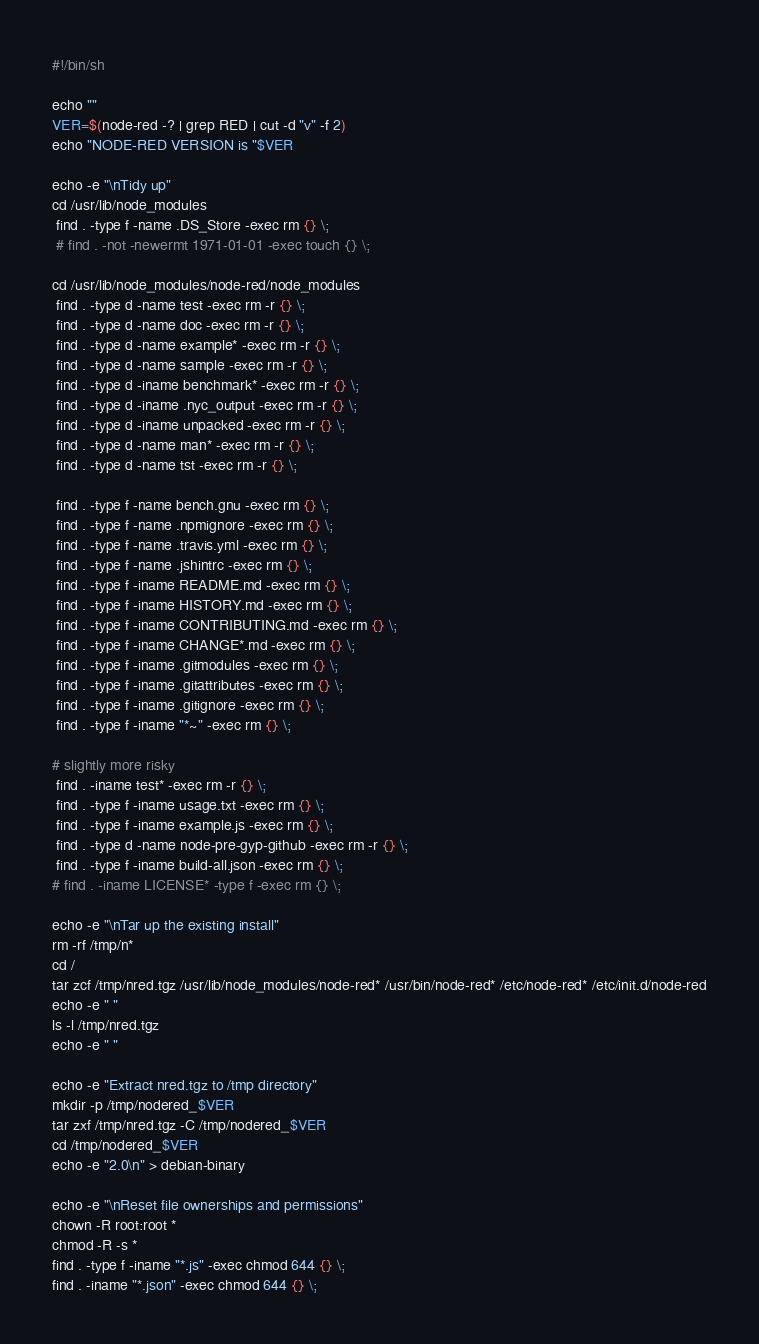Convert code to text. <code><loc_0><loc_0><loc_500><loc_500><_Bash_>#!/bin/sh

echo ""
VER=$(node-red -? | grep RED | cut -d "v" -f 2)
echo "NODE-RED VERSION is "$VER

echo -e "\nTidy up"
cd /usr/lib/node_modules
 find . -type f -name .DS_Store -exec rm {} \;
 # find . -not -newermt 1971-01-01 -exec touch {} \;

cd /usr/lib/node_modules/node-red/node_modules
 find . -type d -name test -exec rm -r {} \;
 find . -type d -name doc -exec rm -r {} \;
 find . -type d -name example* -exec rm -r {} \;
 find . -type d -name sample -exec rm -r {} \;
 find . -type d -iname benchmark* -exec rm -r {} \;
 find . -type d -iname .nyc_output -exec rm -r {} \;
 find . -type d -iname unpacked -exec rm -r {} \;
 find . -type d -name man* -exec rm -r {} \;
 find . -type d -name tst -exec rm -r {} \;

 find . -type f -name bench.gnu -exec rm {} \;
 find . -type f -name .npmignore -exec rm {} \;
 find . -type f -name .travis.yml -exec rm {} \;
 find . -type f -name .jshintrc -exec rm {} \;
 find . -type f -iname README.md -exec rm {} \;
 find . -type f -iname HISTORY.md -exec rm {} \;
 find . -type f -iname CONTRIBUTING.md -exec rm {} \;
 find . -type f -iname CHANGE*.md -exec rm {} \;
 find . -type f -iname .gitmodules -exec rm {} \;
 find . -type f -iname .gitattributes -exec rm {} \;
 find . -type f -iname .gitignore -exec rm {} \;
 find . -type f -iname "*~" -exec rm {} \;

# slightly more risky
 find . -iname test* -exec rm -r {} \;
 find . -type f -iname usage.txt -exec rm {} \;
 find . -type f -iname example.js -exec rm {} \;
 find . -type d -name node-pre-gyp-github -exec rm -r {} \;
 find . -type f -iname build-all.json -exec rm {} \;
# find . -iname LICENSE* -type f -exec rm {} \;

echo -e "\nTar up the existing install"
rm -rf /tmp/n*
cd /
tar zcf /tmp/nred.tgz /usr/lib/node_modules/node-red* /usr/bin/node-red* /etc/node-red* /etc/init.d/node-red
echo -e " "
ls -l /tmp/nred.tgz
echo -e " "

echo -e "Extract nred.tgz to /tmp directory"
mkdir -p /tmp/nodered_$VER
tar zxf /tmp/nred.tgz -C /tmp/nodered_$VER
cd /tmp/nodered_$VER
echo -e "2.0\n" > debian-binary

echo -e "\nReset file ownerships and permissions"
chown -R root:root *
chmod -R -s *
find . -type f -iname "*.js" -exec chmod 644 {} \;
find . -iname "*.json" -exec chmod 644 {} \;</code> 